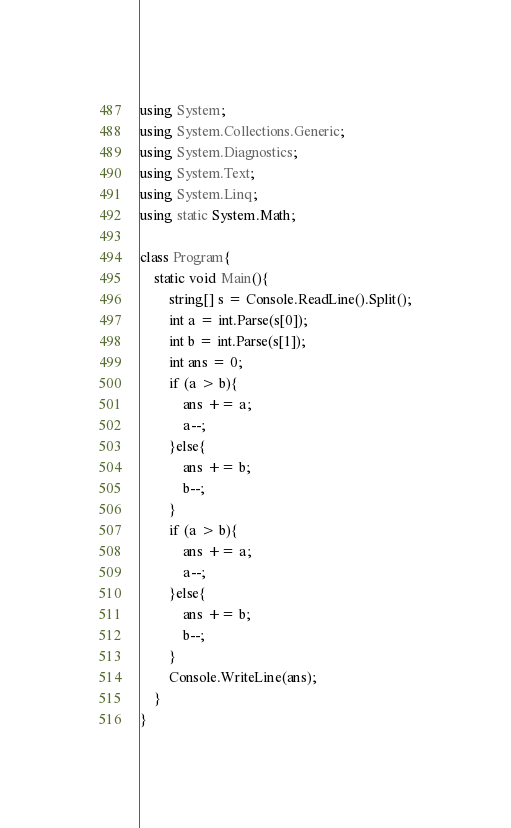<code> <loc_0><loc_0><loc_500><loc_500><_C#_>using System;
using System.Collections.Generic;
using System.Diagnostics;
using System.Text;
using System.Linq;
using static System.Math;

class Program{
	static void Main(){
		string[] s = Console.ReadLine().Split();
		int a = int.Parse(s[0]);
		int b = int.Parse(s[1]);
		int ans = 0;
		if (a > b){
			ans += a;
			a--;
		}else{
			ans += b;
			b--;
		}
		if (a > b){
			ans += a;
			a--;
		}else{
			ans += b;
			b--;
		}
		Console.WriteLine(ans);
	}
}</code> 